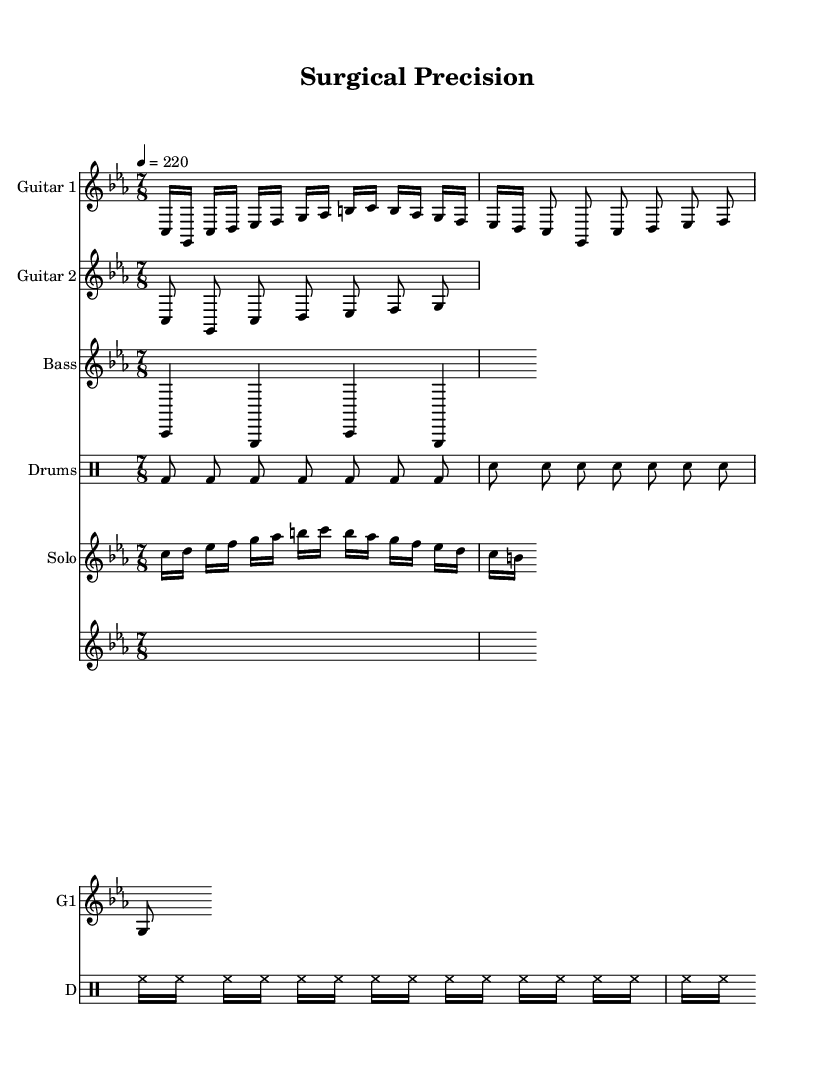What is the key signature of this music? The key signature is C minor, which typically has three flats (B♭, E♭, A♭) but is represented here without the specific flats shown since they are generally implied in the key context.
Answer: C minor What is the time signature of this music? The time signature is written at the beginning and indicates that there are seven eighth notes per measure. This is typically represented as 7/8.
Answer: 7/8 What is the tempo marking indicated? The tempo marking is indicated with "4 = 220," which expresses that the quarter note should be played at a speed of 220 beats per minute.
Answer: 220 How many measures are in the guitar part? By counting each measure indicated in the guitar staff, we see several groupings of notes, which indicate specific measures; based on the notation, there are a total of three measures.
Answer: 3 What type of lyrical theme is represented in the lyrics? The lyrics suggest a theme focused on human anatomy and surgical procedures, indicated by phrases like "Scalpel's edge" and "surgical precision."
Answer: Anatomy What is the primary instrument used for the vocals? The vocal line is represented in a separate staff that indicates it is sung, which can be deduced since the lyrics cannot be played on traditional instruments, revealing that voice is the primary instrument.
Answer: Voice Which instrument plays the bass line? The bass line is clearly labeled in the staff as "Bass," and it plays a specific pattern that supports the harmonic foundation of the piece.
Answer: Bass 